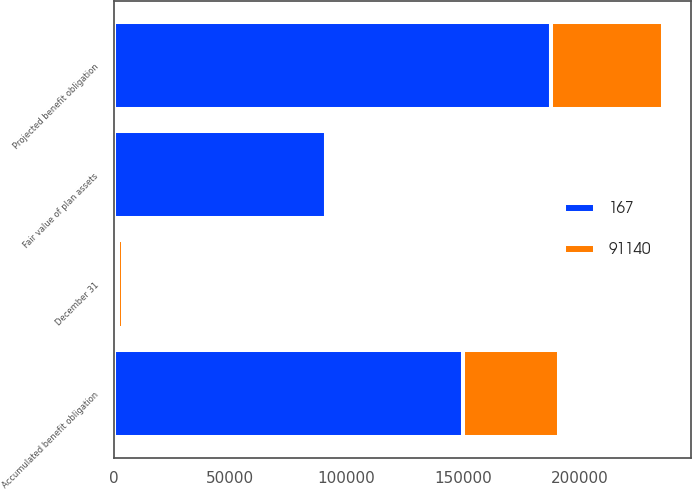<chart> <loc_0><loc_0><loc_500><loc_500><stacked_bar_chart><ecel><fcel>December 31<fcel>Projected benefit obligation<fcel>Accumulated benefit obligation<fcel>Fair value of plan assets<nl><fcel>167<fcel>2005<fcel>187911<fcel>149840<fcel>91140<nl><fcel>91140<fcel>2004<fcel>48178<fcel>41366<fcel>167<nl></chart> 